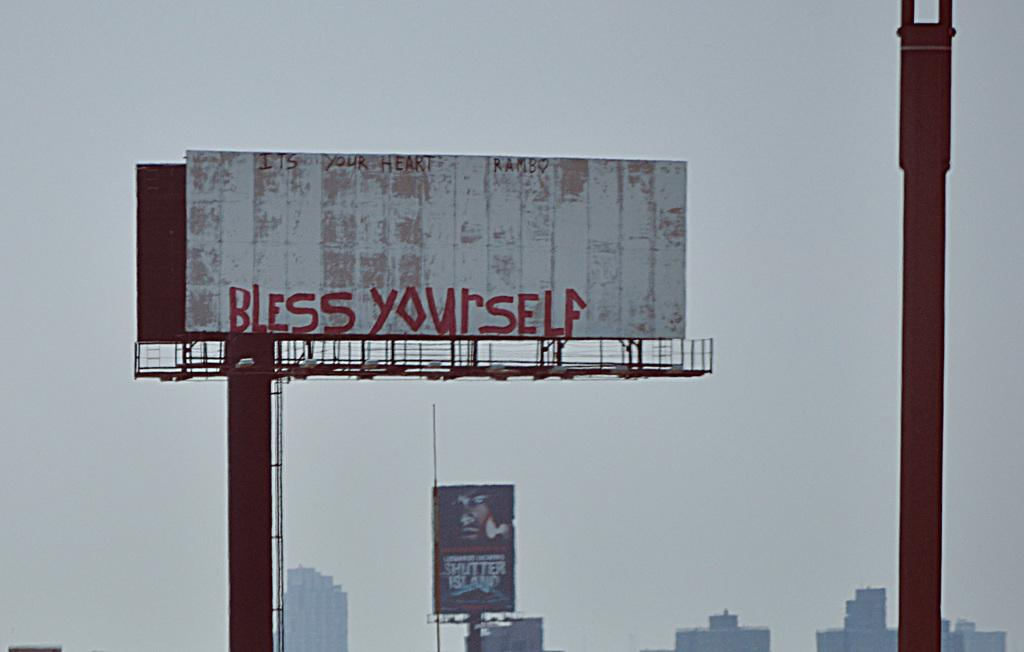<image>
Summarize the visual content of the image. Worn, beaten down looking billboard displays a message in red that reads "Bless Yourself" 